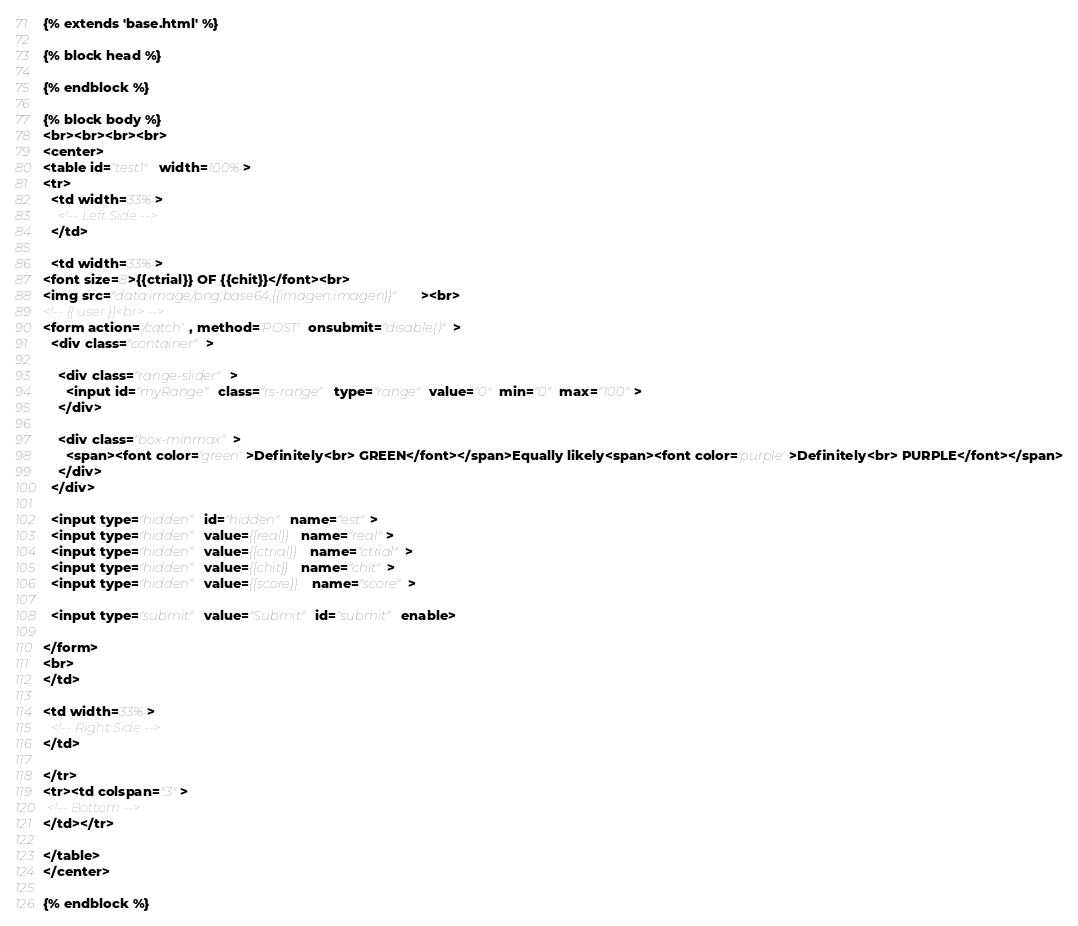Convert code to text. <code><loc_0><loc_0><loc_500><loc_500><_HTML_>{% extends 'base.html' %}

{% block head %}

{% endblock %}

{% block body %}
<br><br><br><br>
<center>
<table id="test1" width=100%>
<tr>
  <td width=33%>
    <!-- Left Side -->    
  </td>

  <td width=33%>
<font size=8>{{ctrial}} OF {{chit}}</font><br>
<img src="data:image/png;base64,{{imagen.imagen}}"><br>
<!-- {{ user }}<br> -->
<form action='/catch', method='POST' onsubmit="disable()">
  <div class="container"> 
     
    <div class="range-slider">
      <input id="myRange" class="rs-range" type="range" value="0" min="0" max="100">      
    </div> 

    <div class="box-minmax">
      <span><font color='green'>Definitely<br> GREEN</font></span>Equally likely<span><font color='purple'>Definitely<br> PURPLE</font></span>
    </div>    
  </div>

  <input type="hidden" id="hidden" name="est"> 
  <input type="hidden" value={{real}} name="real">
  <input type="hidden" value={{ctrial}} name="ctrial">
  <input type="hidden" value={{chit}} name="chit">
  <input type="hidden" value={{score}} name="score">

  <input type="submit" value="Submit" id="submit" enable>
  
</form>
<br>
</td>

<td width=33%>
  <!-- Right Side -->
</td>

</tr>
<tr><td colspan="3">
 <!-- Bottom -->
</td></tr>

</table>
</center>

{% endblock %}

</code> 